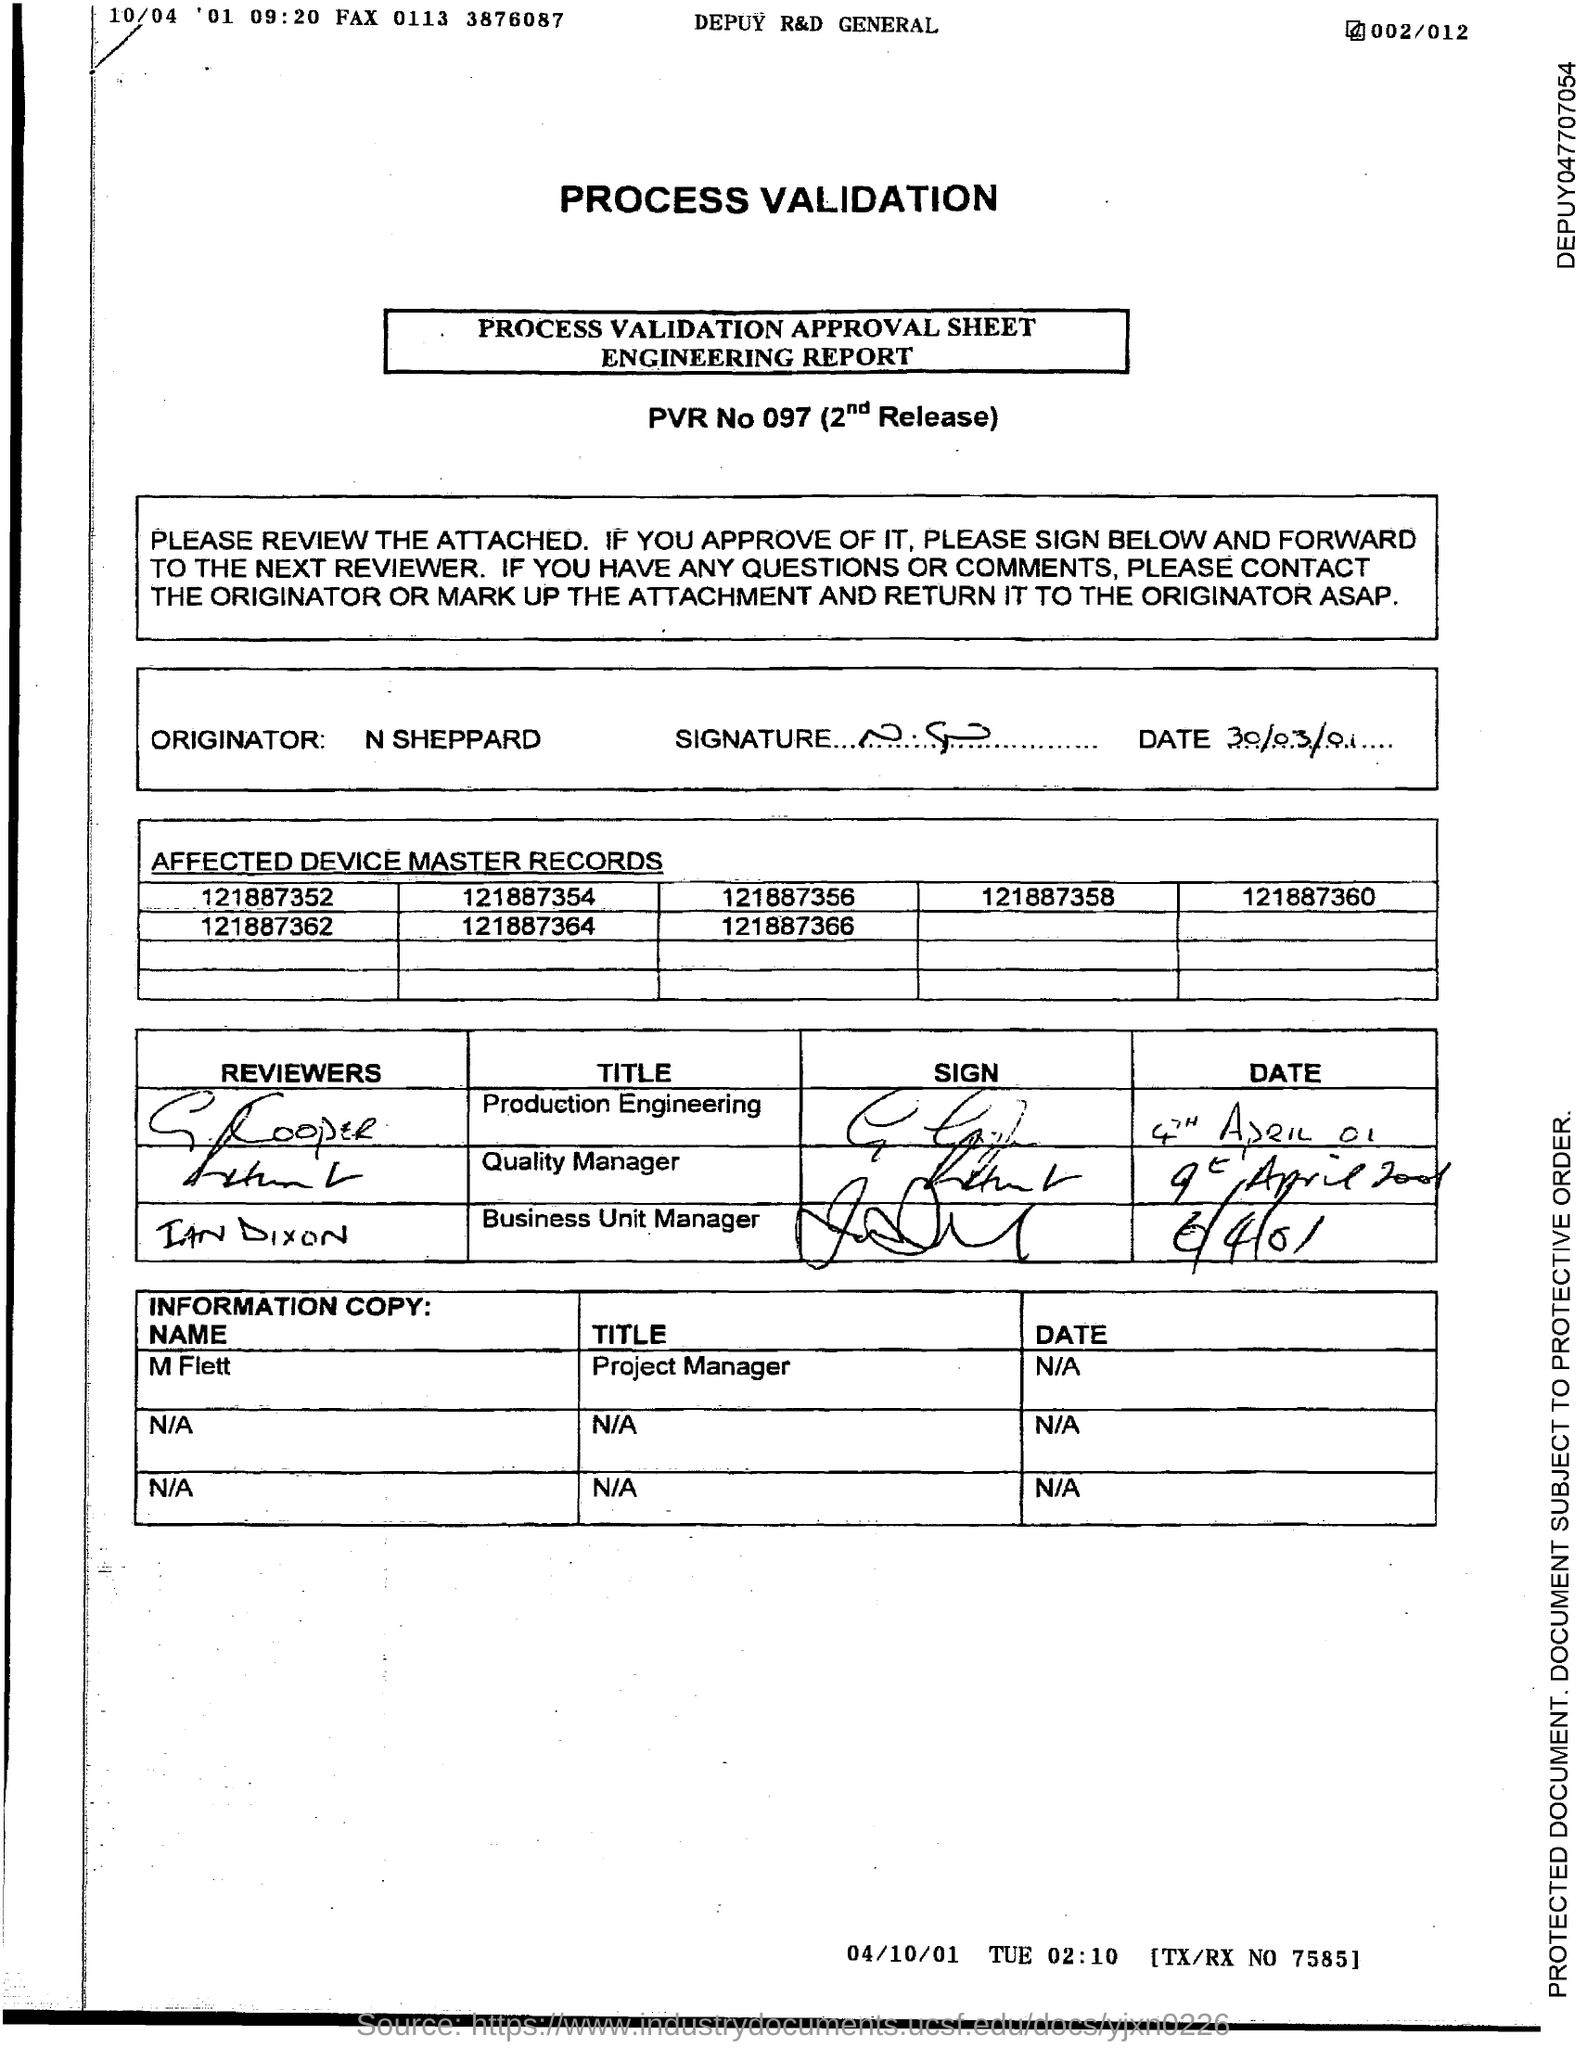Who is the originator mentioned in the process validation approval sheet?
Offer a very short reply. N SHEPPARD. What is the date of the signature of N SHEPPARD?
Keep it short and to the point. 30/03/01. 